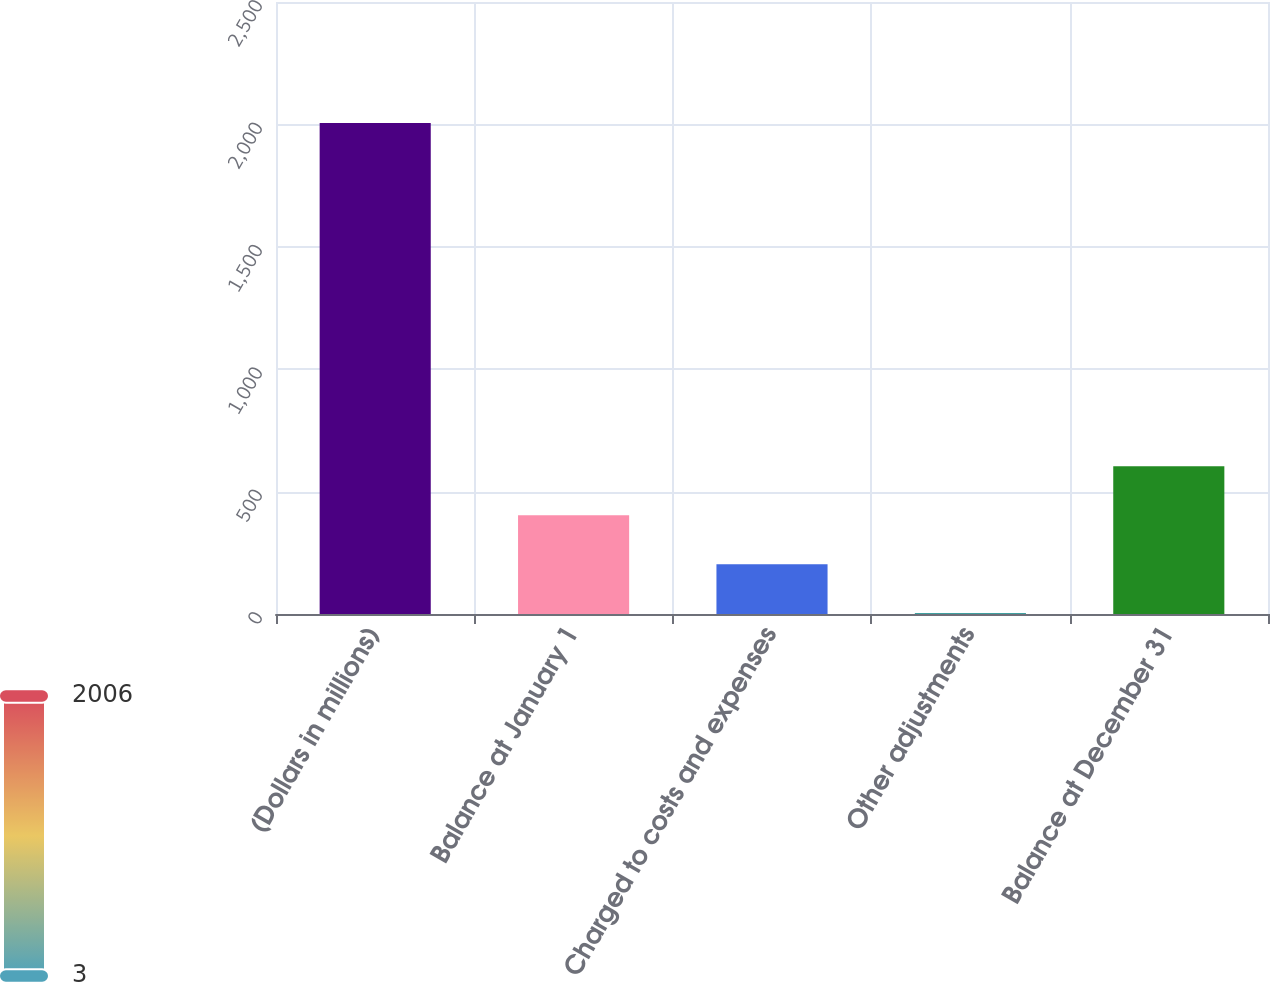<chart> <loc_0><loc_0><loc_500><loc_500><bar_chart><fcel>(Dollars in millions)<fcel>Balance at January 1<fcel>Charged to costs and expenses<fcel>Other adjustments<fcel>Balance at December 31<nl><fcel>2006<fcel>403.6<fcel>203.3<fcel>3<fcel>603.9<nl></chart> 